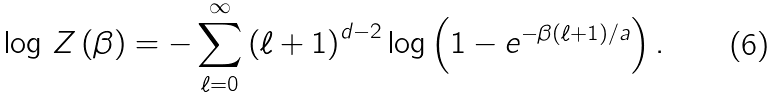<formula> <loc_0><loc_0><loc_500><loc_500>\log \, Z \left ( \beta \right ) = - \sum _ { \ell = 0 } ^ { \infty } \left ( \ell + 1 \right ) ^ { d - 2 } \log \left ( 1 - e ^ { - \beta \left ( \ell + 1 \right ) / a } \right ) .</formula> 